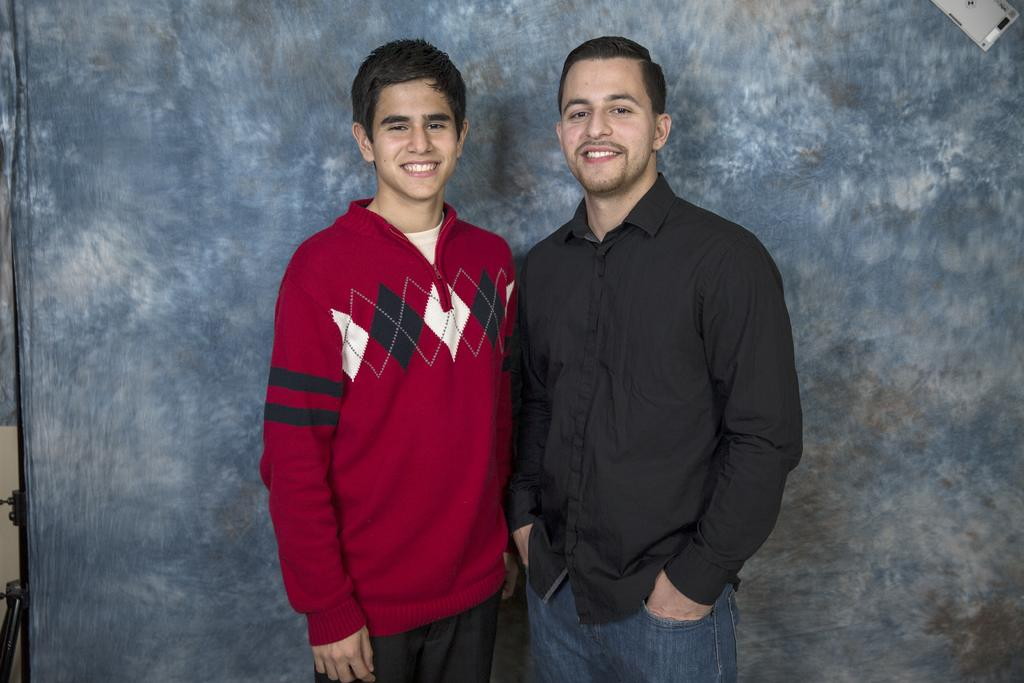How many people are in the image? There are two men in the image. What are the men doing in the image? The men are standing in the image. What expressions do the men have in the image? Both men are smiling in the image. What can be seen behind the men in the image? There is a background cloth present in the image. How many kittens are sitting on the shoulders of the men in the image? There are no kittens present in the image. What is the men's desire in the image? The provided facts do not give any information about the men's desires, so we cannot answer this question. 